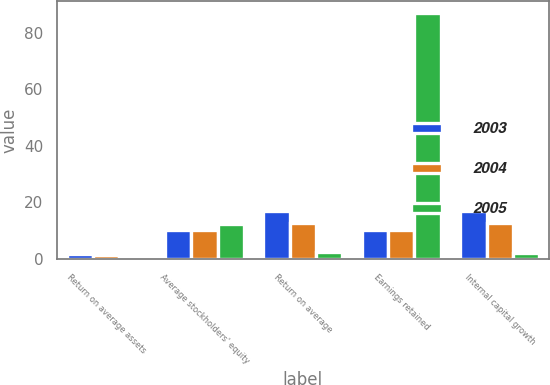Convert chart to OTSL. <chart><loc_0><loc_0><loc_500><loc_500><stacked_bar_chart><ecel><fcel>Return on average assets<fcel>Average stockholders' equity<fcel>Return on average<fcel>Earnings retained<fcel>Internal capital growth<nl><fcel>2003<fcel>1.78<fcel>10.43<fcel>17.09<fcel>10.43<fcel>16.95<nl><fcel>2004<fcel>1.34<fcel>10.38<fcel>12.9<fcel>10.43<fcel>12.9<nl><fcel>2005<fcel>0.32<fcel>12.44<fcel>2.58<fcel>86.8<fcel>2.24<nl></chart> 